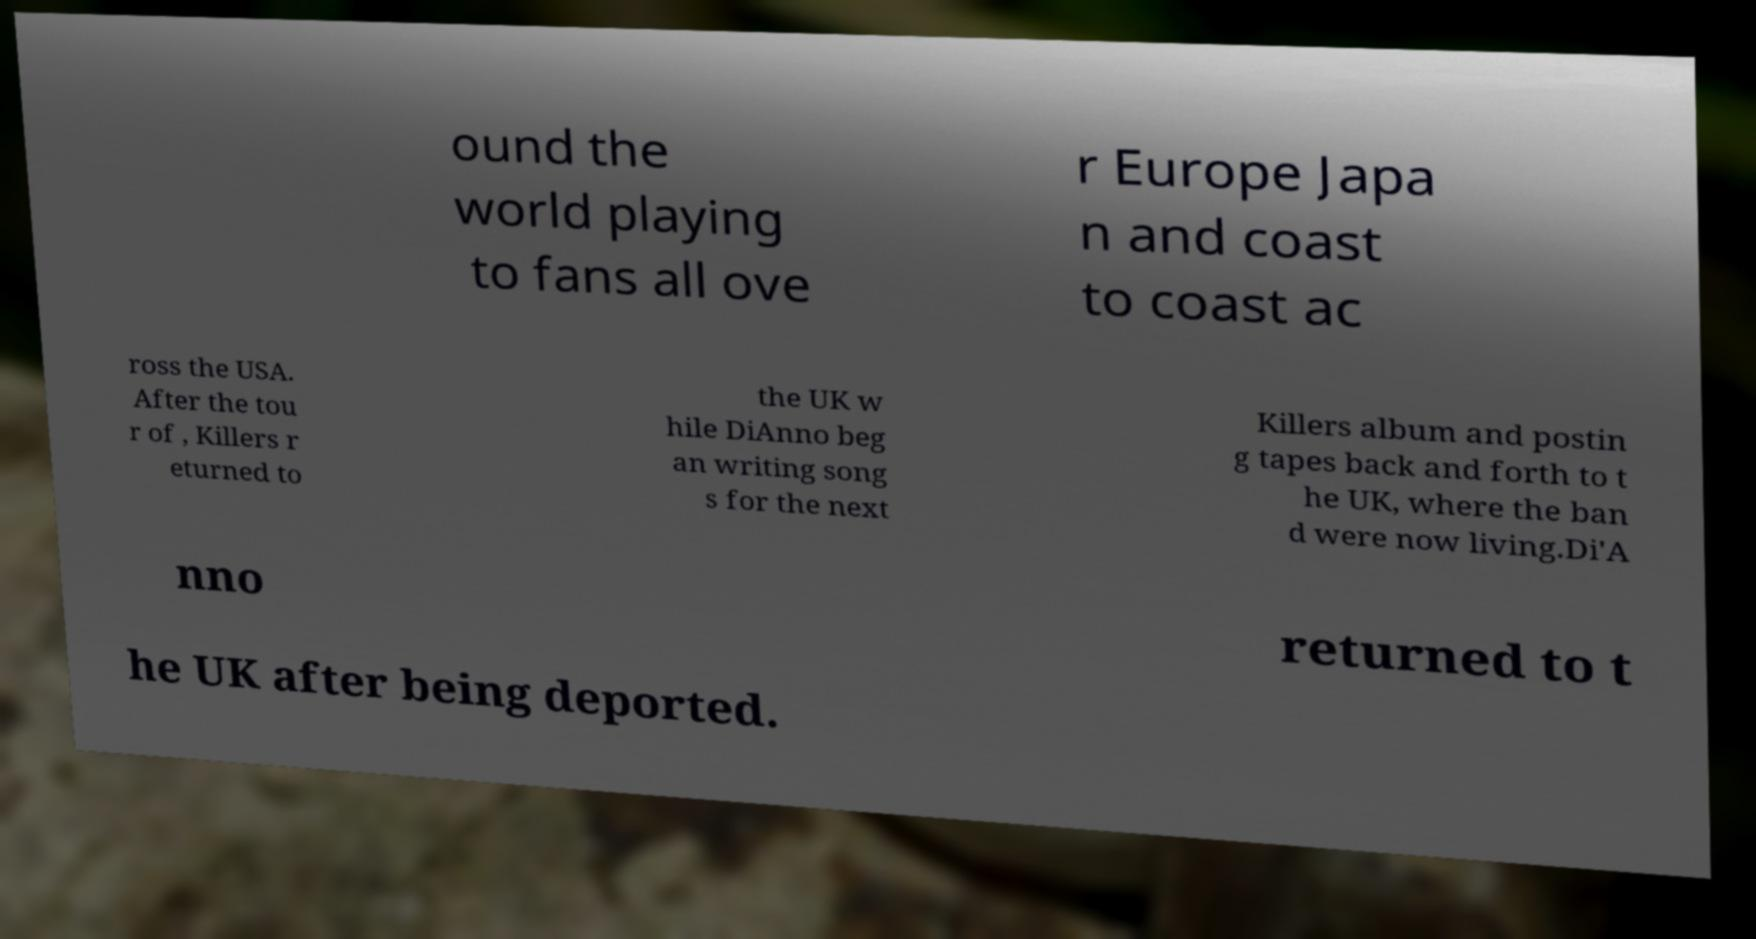Can you read and provide the text displayed in the image?This photo seems to have some interesting text. Can you extract and type it out for me? ound the world playing to fans all ove r Europe Japa n and coast to coast ac ross the USA. After the tou r of , Killers r eturned to the UK w hile DiAnno beg an writing song s for the next Killers album and postin g tapes back and forth to t he UK, where the ban d were now living.Di'A nno returned to t he UK after being deported. 